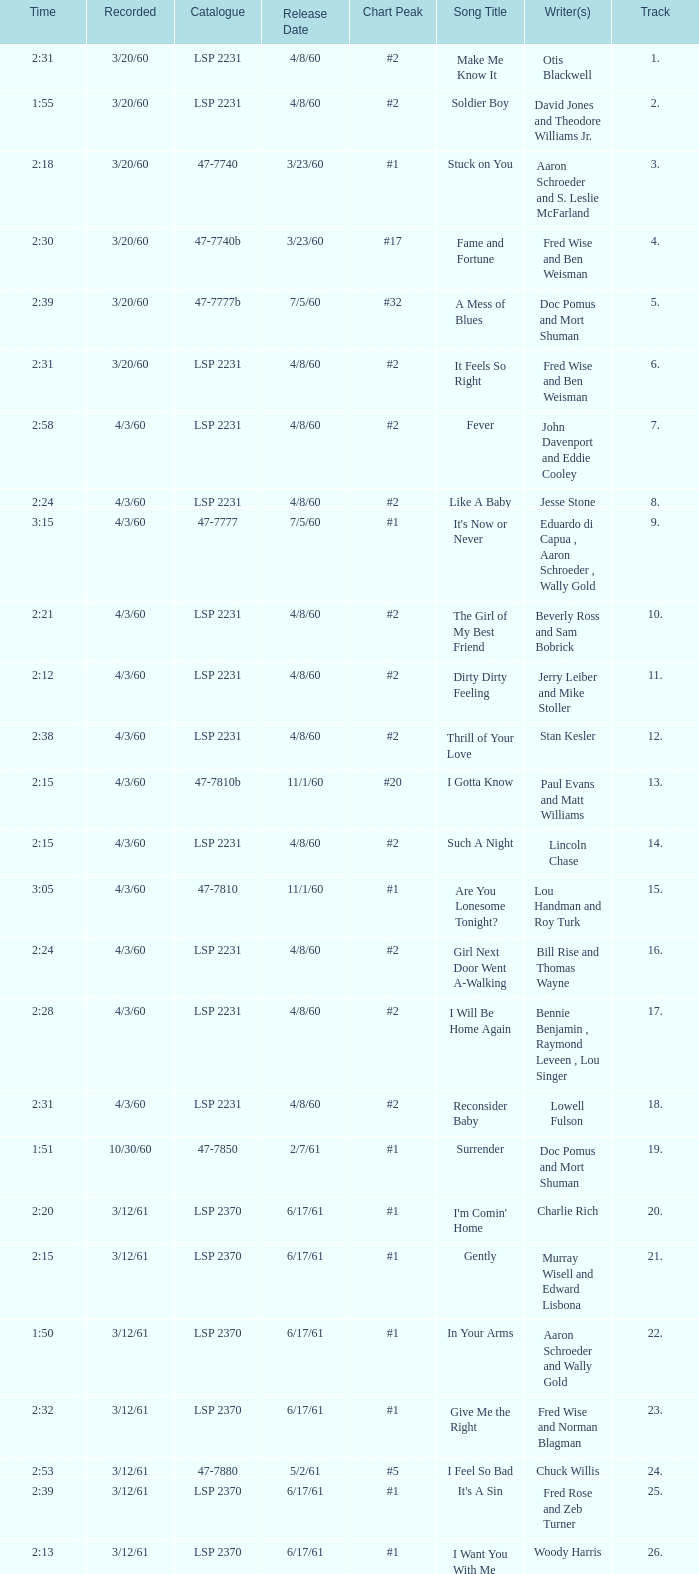In the catalogue lsp 2231, who are the writer(s) for songs with track numbers below 17? Otis Blackwell, David Jones and Theodore Williams Jr., Fred Wise and Ben Weisman, John Davenport and Eddie Cooley, Jesse Stone, Beverly Ross and Sam Bobrick, Jerry Leiber and Mike Stoller, Stan Kesler, Lincoln Chase, Bill Rise and Thomas Wayne. 